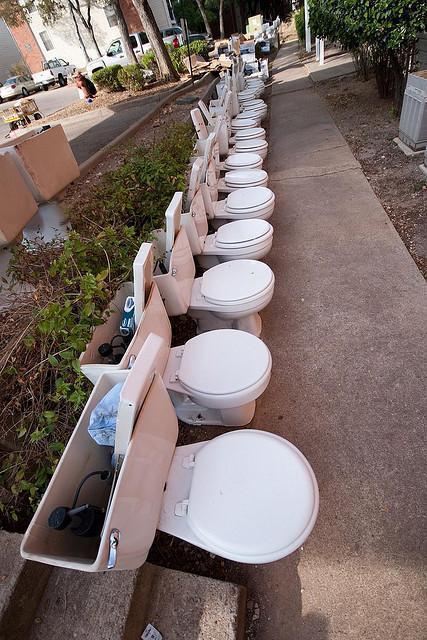What's happening with these toilets?
Answer the question by selecting the correct answer among the 4 following choices.
Options: Discarding them, cleaning them, selling them, displaying them. Displaying them. 